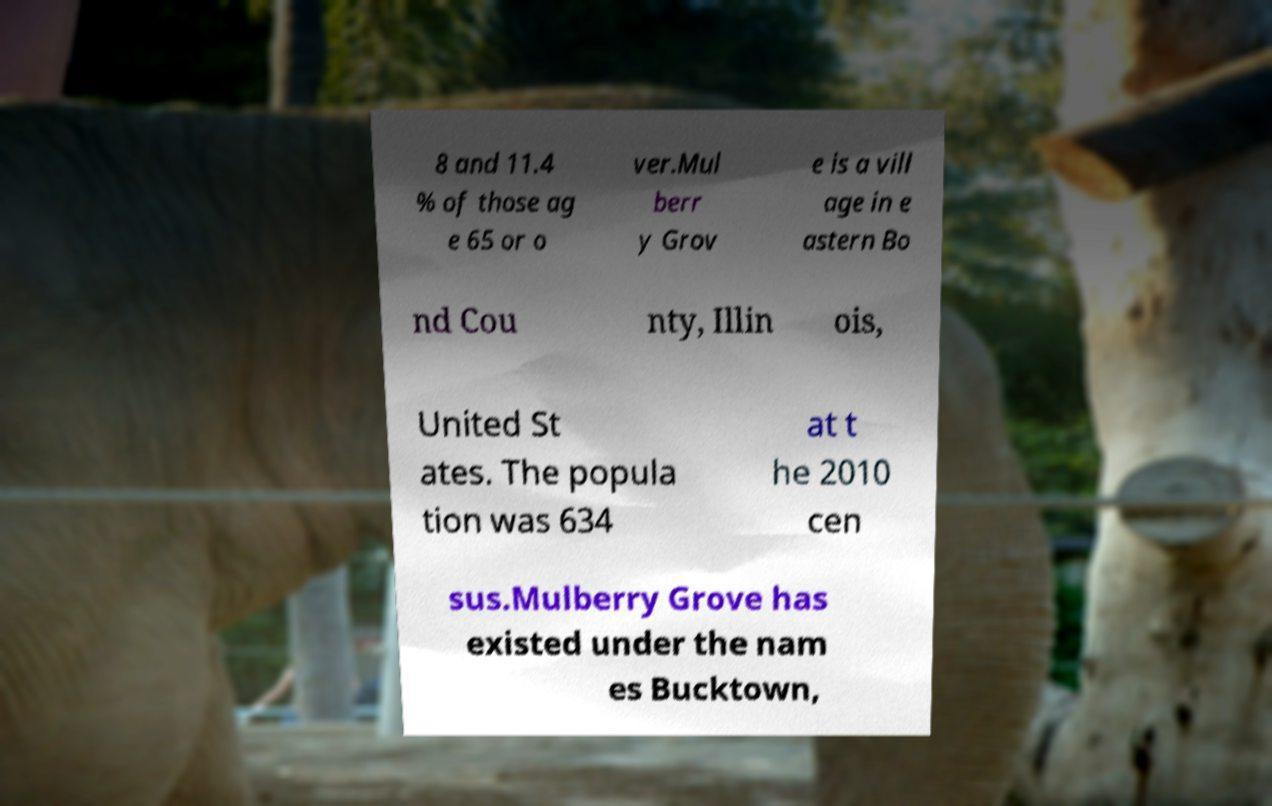Can you read and provide the text displayed in the image?This photo seems to have some interesting text. Can you extract and type it out for me? 8 and 11.4 % of those ag e 65 or o ver.Mul berr y Grov e is a vill age in e astern Bo nd Cou nty, Illin ois, United St ates. The popula tion was 634 at t he 2010 cen sus.Mulberry Grove has existed under the nam es Bucktown, 